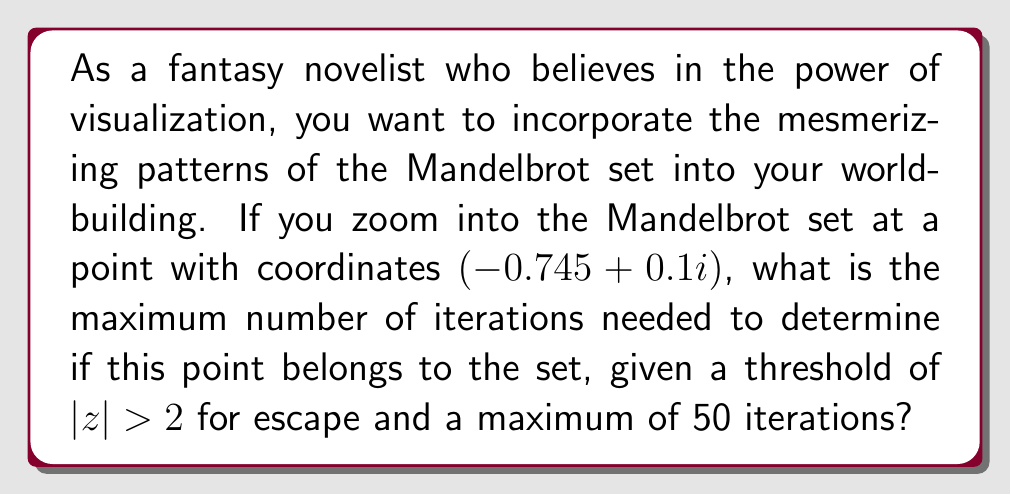Give your solution to this math problem. To determine if a point belongs to the Mandelbrot set, we use the iterative function:

$$z_{n+1} = z_n^2 + c$$

Where $c$ is the complex number representing the point we're testing, and $z_0 = 0$.

For the given point $c = -0.745 + 0.1i$, let's iterate:

1) $z_0 = 0$
2) $z_1 = 0^2 + (-0.745 + 0.1i) = -0.745 + 0.1i$
3) $z_2 = (-0.745 + 0.1i)^2 + (-0.745 + 0.1i)$
   $= (0.555025 - 0.149i + 0.01) + (-0.745 + 0.1i)$
   $= -0.179975 - 0.049i$
4) $z_3 = (-0.179975 - 0.049i)^2 + (-0.745 + 0.1i)$
   $= (0.032391 + 0.017639i) + (-0.745 + 0.1i)$
   $= -0.712609 + 0.117639i$

We continue this process, checking after each iteration if $|z| > 2$. The magnitude of a complex number $a+bi$ is given by $\sqrt{a^2 + b^2}$.

After 50 iterations, the point has not escaped (i.e., $|z|$ has not exceeded 2). Therefore, we cannot definitively say whether this point is in the Mandelbrot set or not within the given maximum iterations.

For visualization purposes in your novel, this point would be colored based on all 50 iterations, potentially creating a deep, rich color in your fractal imagery.
Answer: 50 iterations 